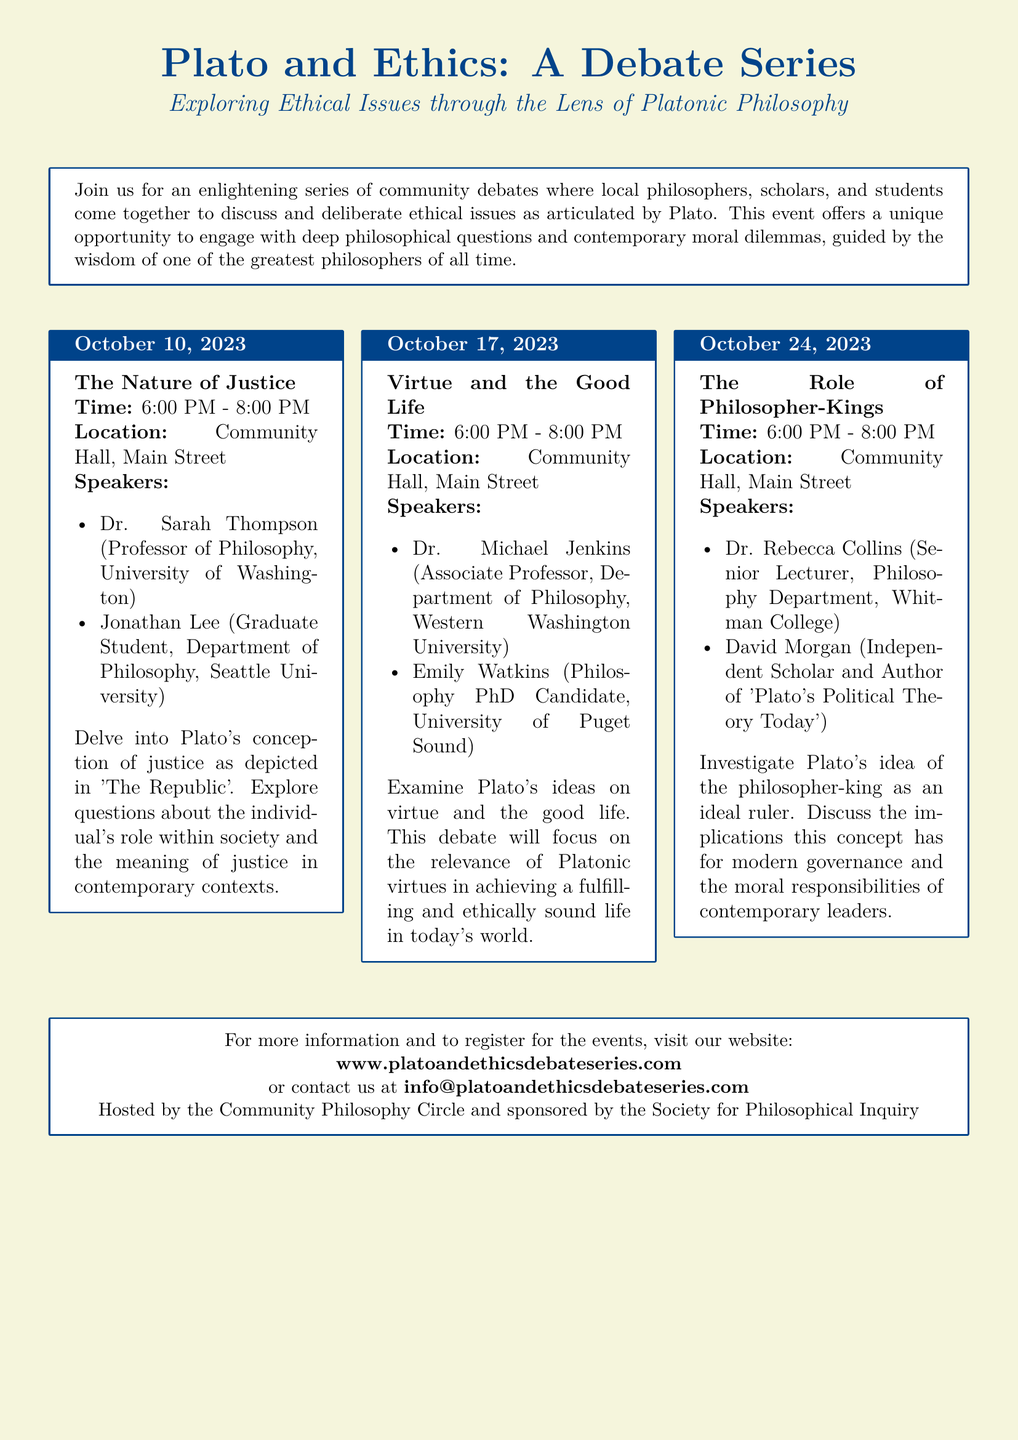What is the title of the event series? The title of the event series is found in the header of the flyer.
Answer: Plato and Ethics: A Debate Series When is the debate on "The Nature of Justice"? The date for this debate is provided in the schedule section of the flyer.
Answer: October 10, 2023 Who is one of the speakers for the debate on "Virtue and the Good Life"? The speaker names are listed under each debate topic.
Answer: Dr. Michael Jenkins What time do the debates start? The start time for all debates is mentioned in each event box.
Answer: 6:00 PM What is the location of the debates? The location is described in each event box.
Answer: Community Hall, Main Street Which debate talks about the philosopher-king? This is determined by analyzing the titles of each debate.
Answer: The Role of Philosopher-Kings How many debates are listed in the document? By counting the number of event boxes, the total can be determined.
Answer: Three What organization is hosting the event? The hosting organization is mentioned at the end of the flyer.
Answer: Community Philosophy Circle What website can participants visit for more information? The website is provided in the contact information section.
Answer: www.platoandethicsdebateseries.com 